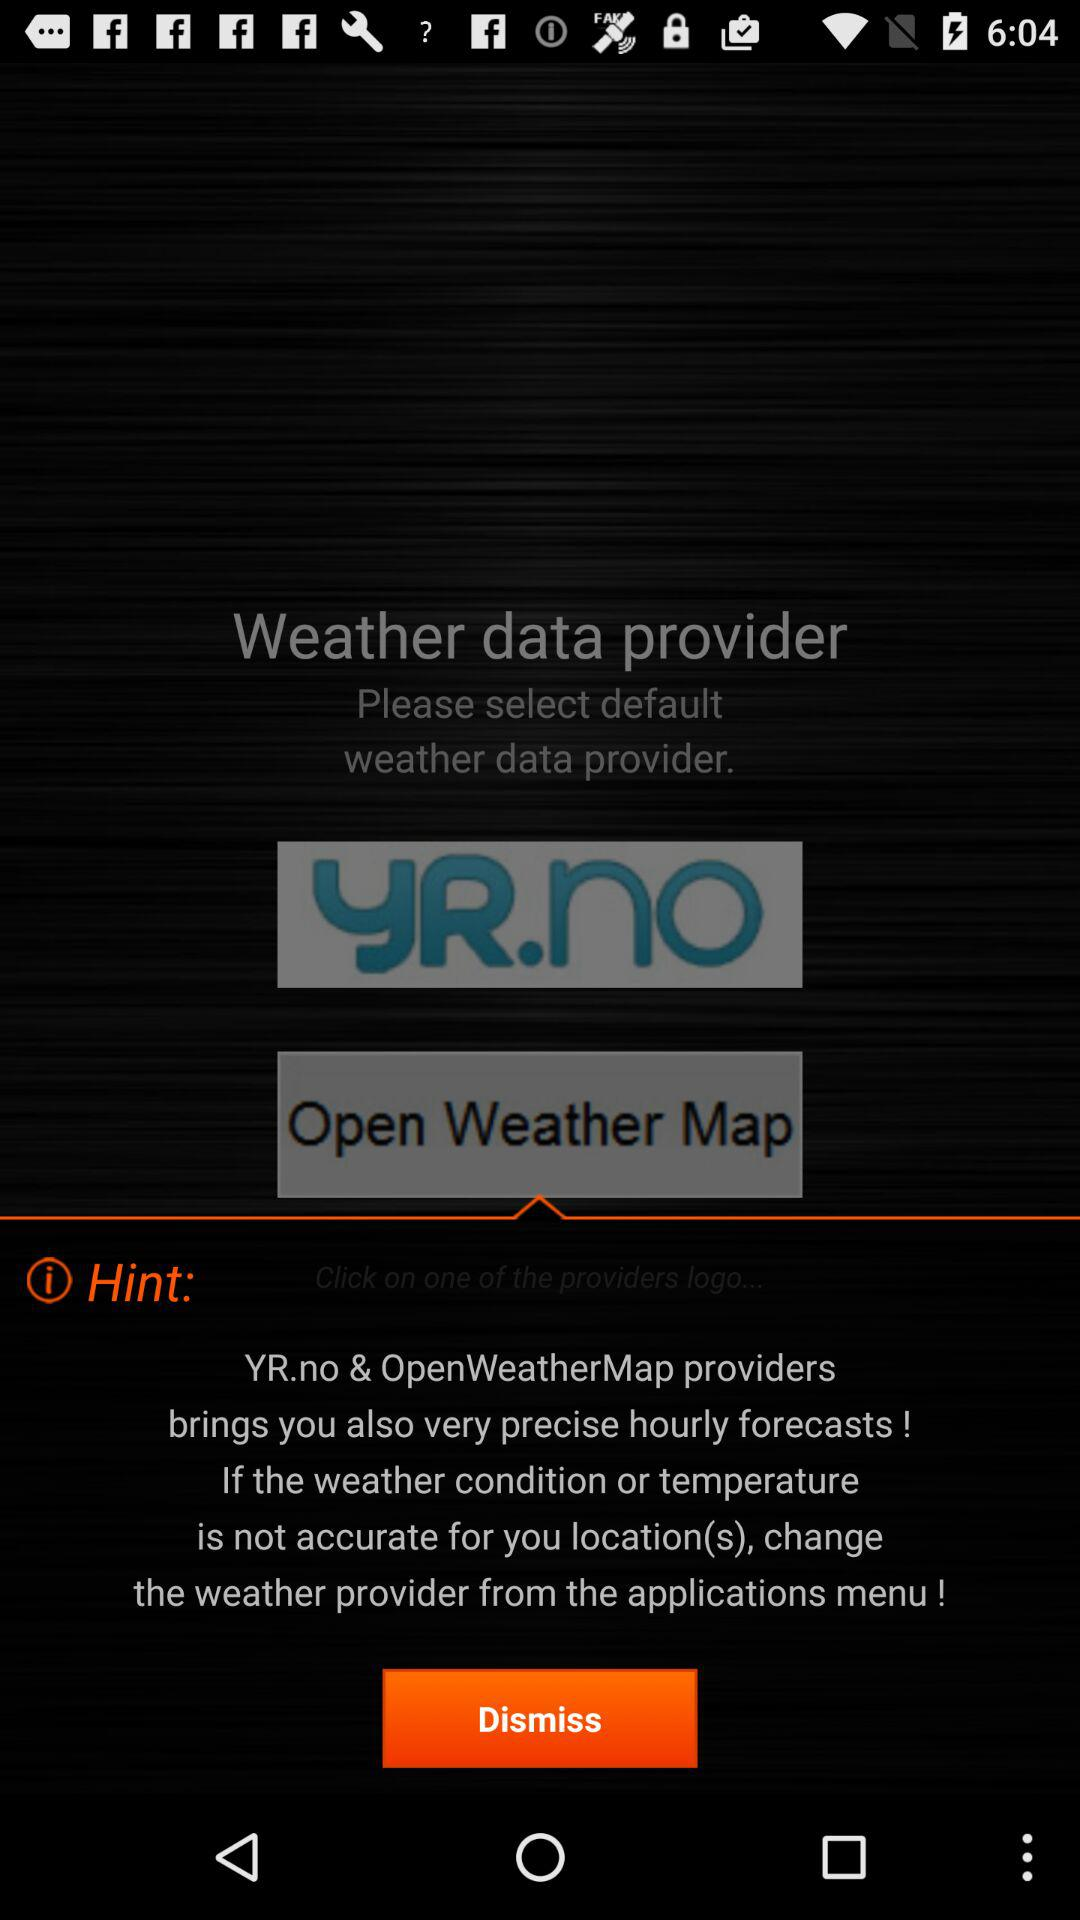How many weather data providers are there?
Answer the question using a single word or phrase. 2 